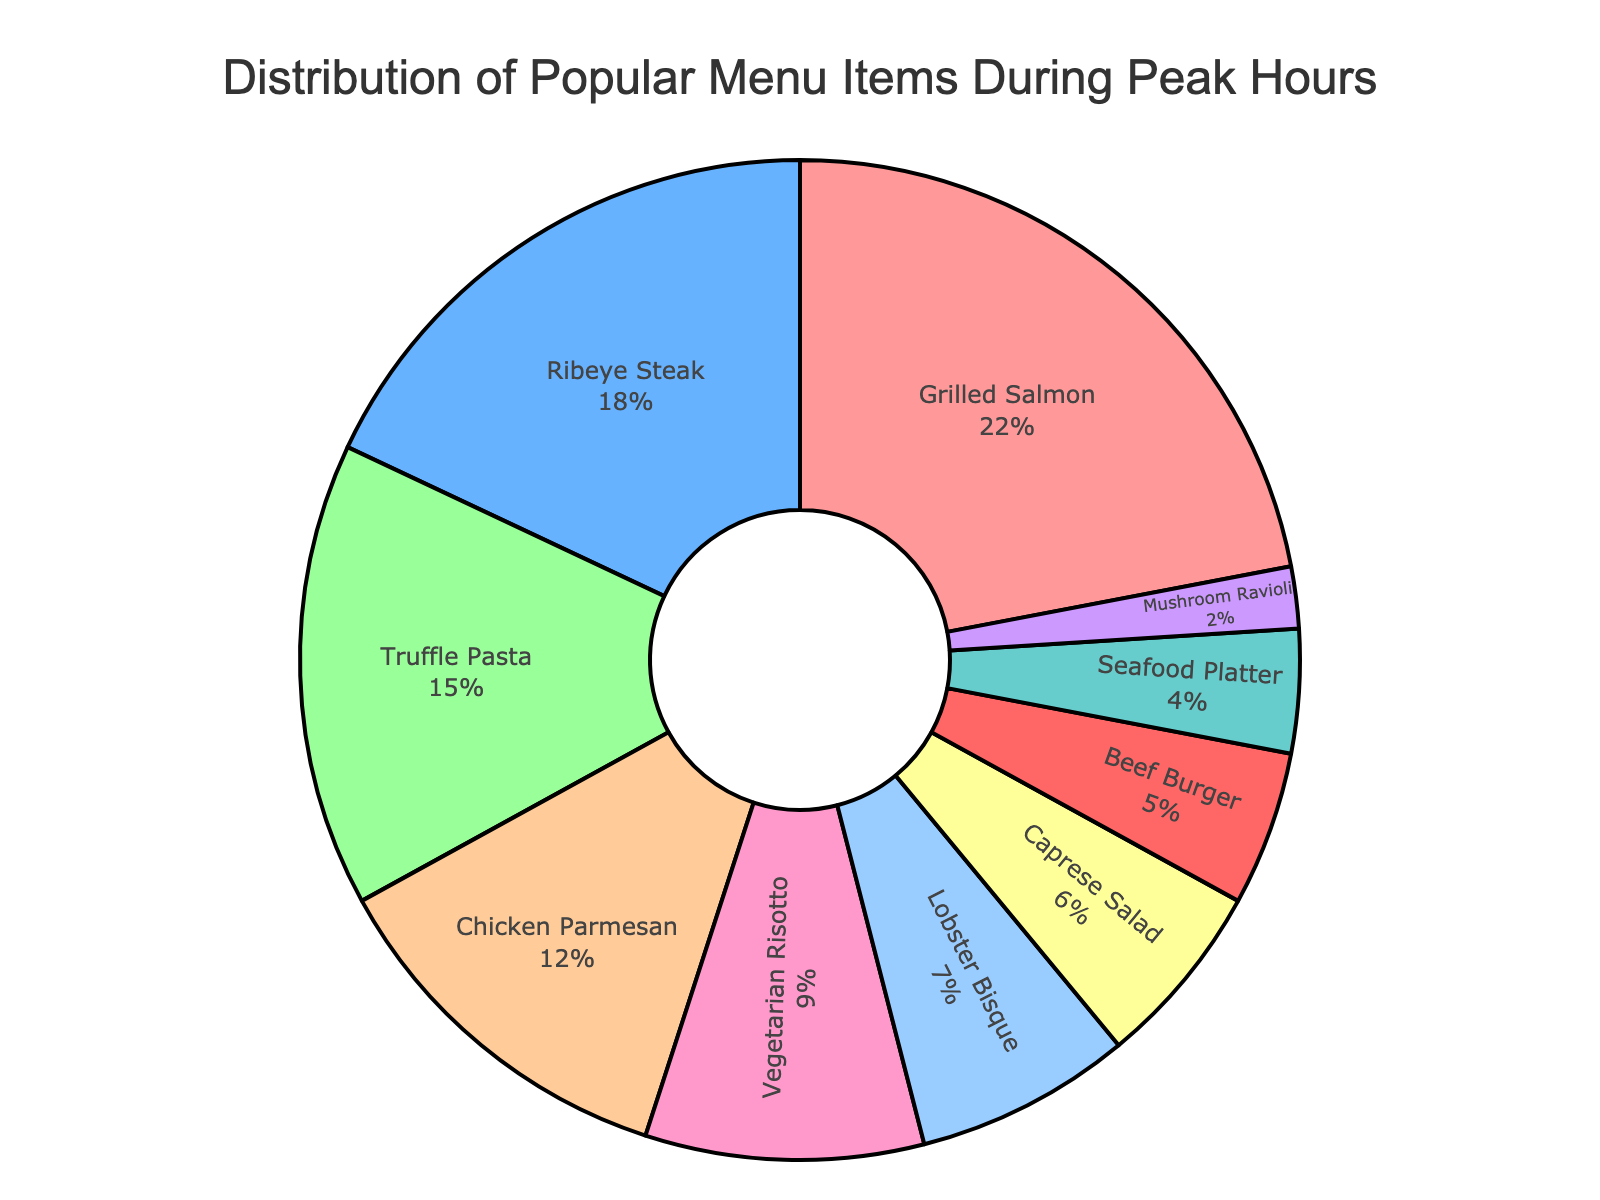What's the most popular menu item during peak hours? By observing the largest segment in the pie chart, we can determine that the Grilled Salmon has the largest percentage.
Answer: Grilled Salmon Which menu item has the least percentage of orders during peak hours? By identifying the smallest segment in the pie chart, we can see that Mushroom Ravioli has the smallest percentage.
Answer: Mushroom Ravioli How much more popular is Ribeye Steak compared to Beef Burger? Ribeye Steak has a percentage of 18%, and Beef Burger has 5%. Subtract 5% from 18% to get the difference.
Answer: 13% What is the combined percentage of orders for Truffle Pasta, Chicken Parmesan, and Vegetarian Risotto? Add the percentages for Truffle Pasta (15%), Chicken Parmesan (12%), and Vegetarian Risotto (9%). The combined percentage is 15% + 12% + 9% = 36%.
Answer: 36% Which menu item is more popular, Caprese Salad or Seafood Platter? By comparing the percentages of Caprese Salad (6%) and Seafood Platter (4%), we see that Caprese Salad has a higher percentage.
Answer: Caprese Salad If you sum the percentages of the least popular four items, what is the total percentage? Add the percentages of Mushroom Ravioli (2%), Seafood Platter (4%), Beef Burger (5%), and Caprese Salad (6%). The total is 2% + 4% + 5% + 6% = 17%.
Answer: 17% What's the average percentage of the top three most popular menu items? The top three items are Grilled Salmon (22%), Ribeye Steak (18%), and Truffle Pasta (15%). Sum them up and divide by 3. (22% + 18% + 15%) / 3 = 55% / 3 ≈ 18.33%.
Answer: 18.33% Which menu items occupy a larger combined share than Grilled Salmon? Grilled Salmon has 22%. Adding Chicken Parmesan (12%) and Truffle Pasta (15%) gives 27%, which is more than 22%.
Answer: Chicken Parmesan and Truffle Pasta Is Lobster Bisque more popular than Vegetarian Risotto? By comparing the percentages, Lobster Bisque has 7% and Vegetarian Risotto has 9%. Therefore, Lobster Bisque is not more popular.
Answer: No 